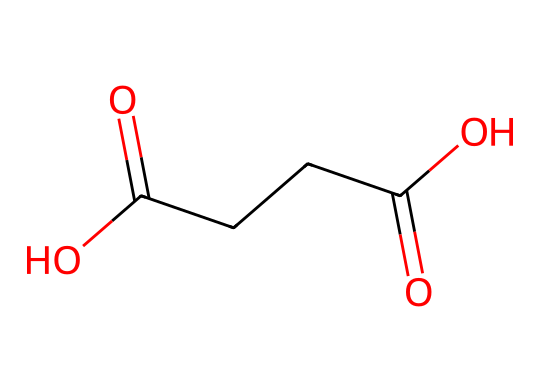What is the total number of carbon atoms in this chemical? By examining the SMILES representation, we see that there are three distinct carbon atoms depicted, represented as 'C' characters in the structure, confirming a total count of three.
Answer: 3 How many carboxylic acid functional groups are present in this molecule? The molecule's structure includes two carboxylic acid (–COOH) groups, identifiable from the 'C(=O)O' portions within the SMILES representation. This indicates that these functional groups appear twice.
Answer: 2 Is this polymer likely to be soluble in water? Since this polymer contains multiple carboxylic acid groups, it is generally indicative of a higher polarity and thus a likelihood of being soluble in water.
Answer: Yes What is the significance of the presence of carbonyl groups in this polymer? The carbonyl groups (C=O) indicate potential sites for further reactions and can enhance the polymer's compatibility with other materials, making it more versatile in applications.
Answer: Versatility Does this chemical structure suggest that it is a natural or synthetic polymer? The presence of carboxylic acid functional groups is common in natural polymers, often derived from organic sources, indicating that this compound is likely a natural polymer.
Answer: Natural 